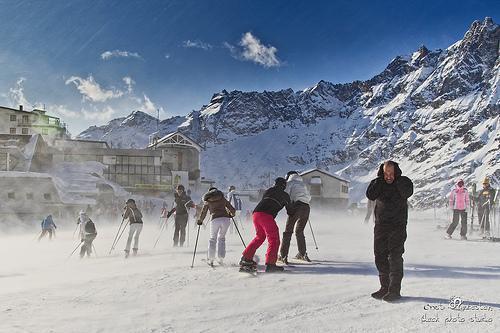How many men holding his ears?
Give a very brief answer. 1. 